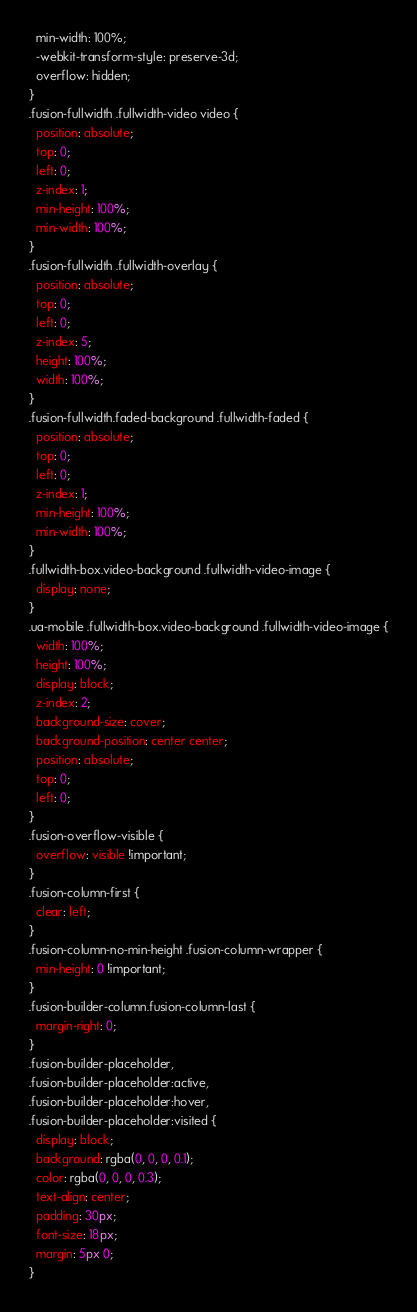<code> <loc_0><loc_0><loc_500><loc_500><_CSS_>  min-width: 100%;
  -webkit-transform-style: preserve-3d;
  overflow: hidden;
}
.fusion-fullwidth .fullwidth-video video {
  position: absolute;
  top: 0;
  left: 0;
  z-index: 1;
  min-height: 100%;
  min-width: 100%;
}
.fusion-fullwidth .fullwidth-overlay {
  position: absolute;
  top: 0;
  left: 0;
  z-index: 5;
  height: 100%;
  width: 100%;
}
.fusion-fullwidth.faded-background .fullwidth-faded {
  position: absolute;
  top: 0;
  left: 0;
  z-index: 1;
  min-height: 100%;
  min-width: 100%;
}
.fullwidth-box.video-background .fullwidth-video-image {
  display: none;
}
.ua-mobile .fullwidth-box.video-background .fullwidth-video-image {
  width: 100%;
  height: 100%;
  display: block;
  z-index: 2;
  background-size: cover;
  background-position: center center;
  position: absolute;
  top: 0;
  left: 0;
}
.fusion-overflow-visible {
  overflow: visible !important;
}
.fusion-column-first {
  clear: left;
}
.fusion-column-no-min-height .fusion-column-wrapper {
  min-height: 0 !important;
}
.fusion-builder-column.fusion-column-last {
  margin-right: 0;
}
.fusion-builder-placeholder,
.fusion-builder-placeholder:active,
.fusion-builder-placeholder:hover,
.fusion-builder-placeholder:visited {
  display: block;
  background: rgba(0, 0, 0, 0.1);
  color: rgba(0, 0, 0, 0.3);
  text-align: center;
  padding: 30px;
  font-size: 18px;
  margin: 5px 0;
}
</code> 